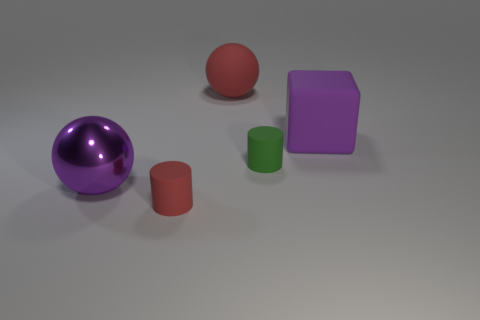Add 4 purple spheres. How many objects exist? 9 Subtract all cylinders. How many objects are left? 3 Subtract 0 cyan blocks. How many objects are left? 5 Subtract all tiny yellow cubes. Subtract all purple objects. How many objects are left? 3 Add 1 red cylinders. How many red cylinders are left? 2 Add 1 big green blocks. How many big green blocks exist? 1 